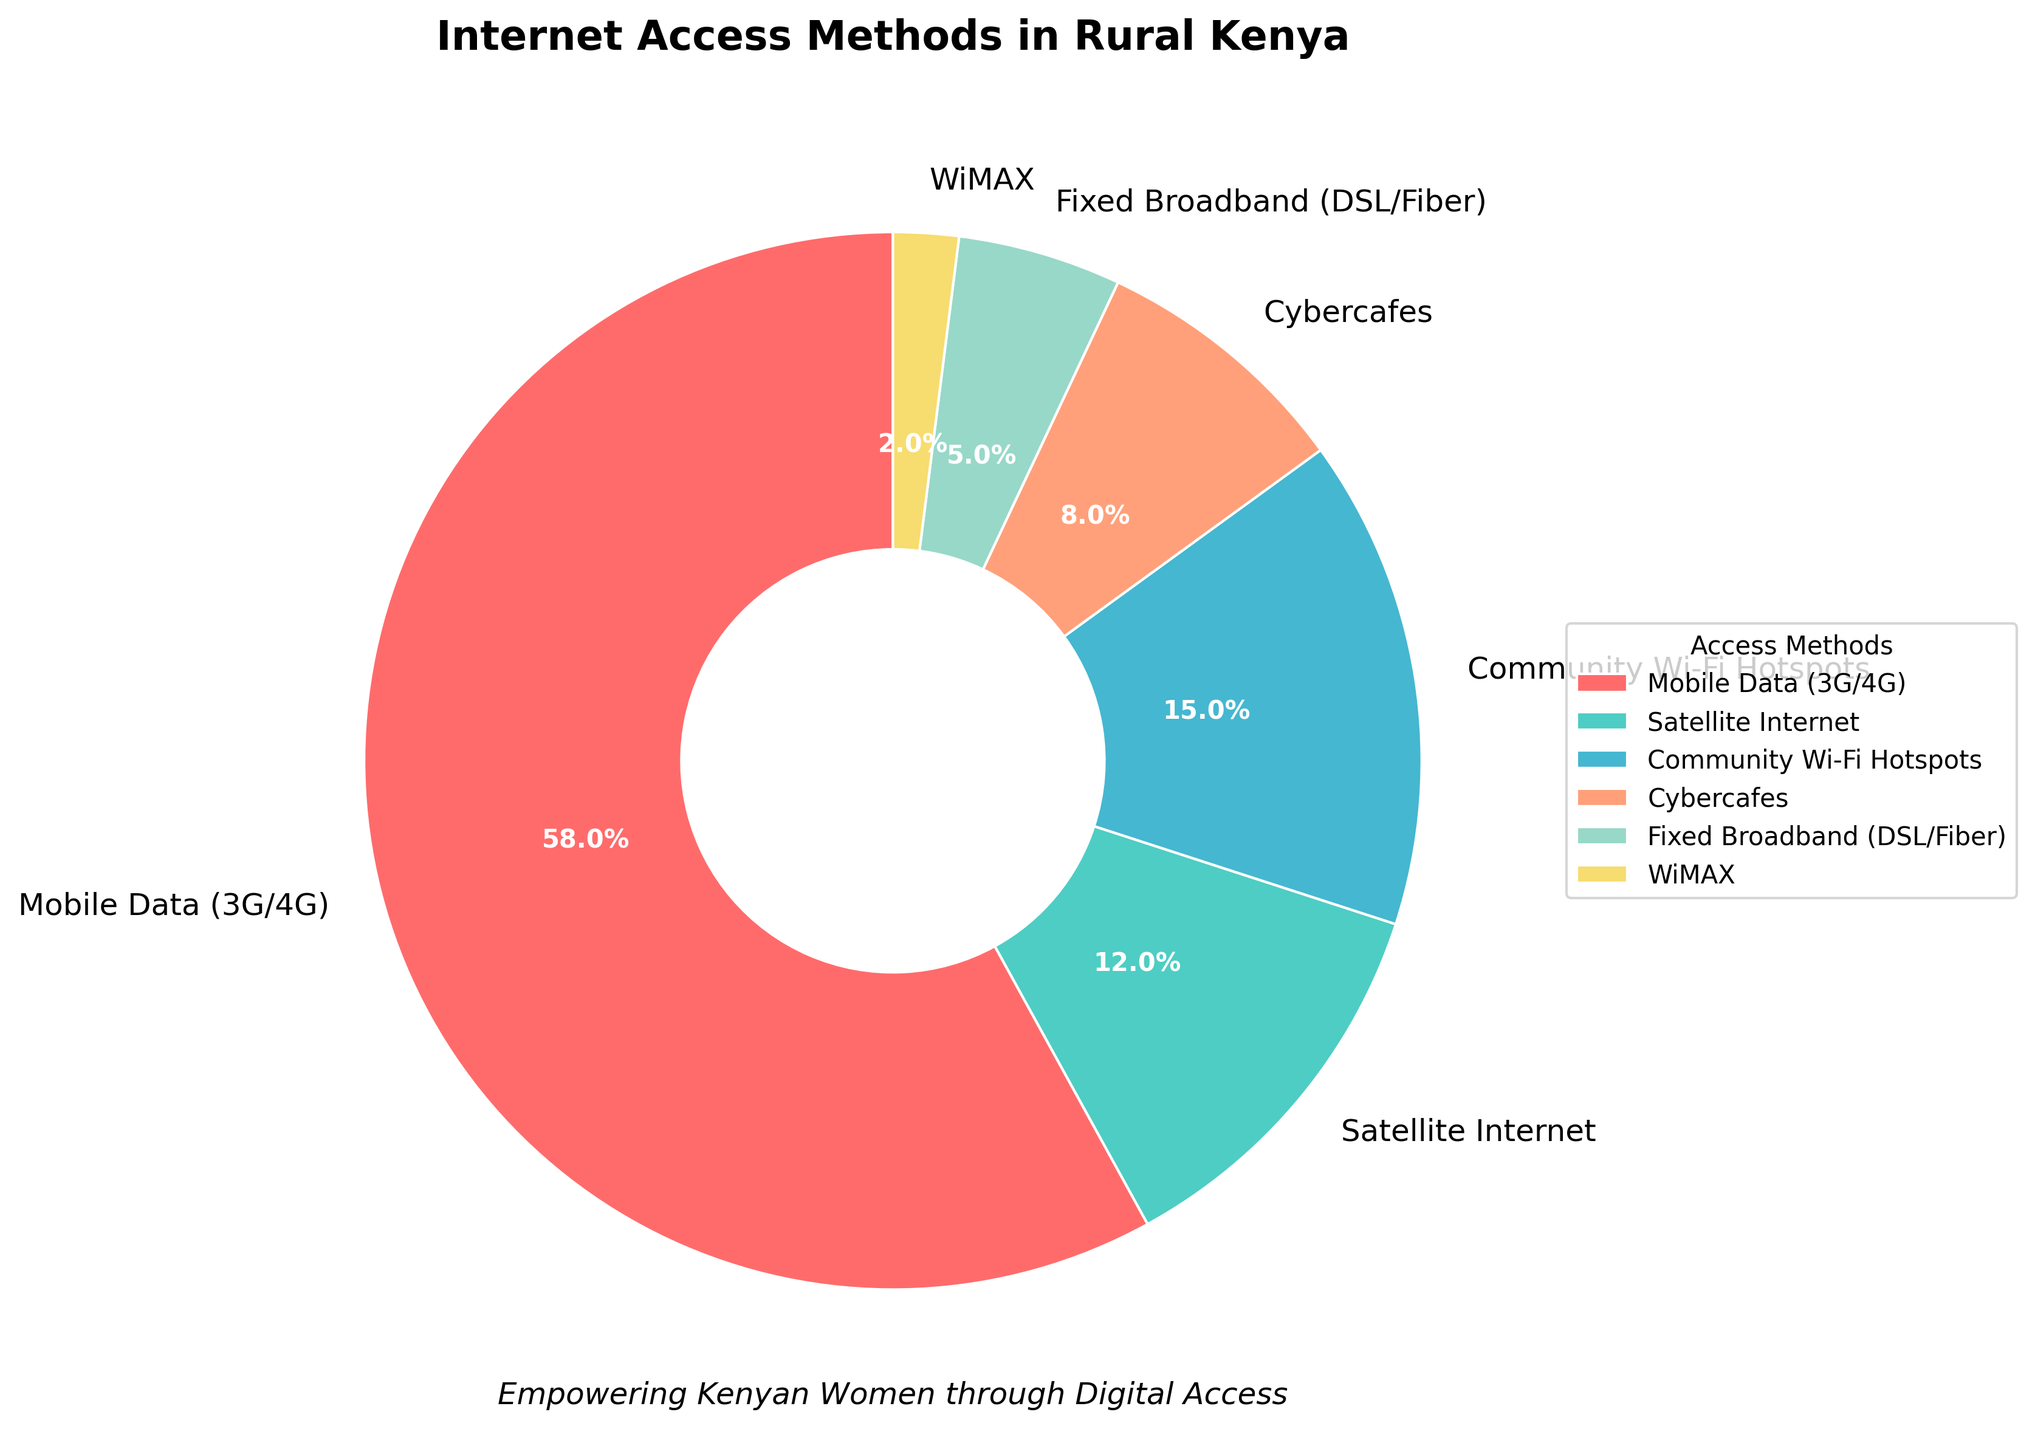What percentage of rural Kenya’s internet access comes from mobile data? Mobile data represents 58% of the total internet access methods. This can be directly observed from the chart's labeling.
Answer: 58% Which internet access method is more common in rural Kenya, satellite internet or community Wi-Fi hotspots? Community Wi-Fi hotspots account for 15% of the internet access compared to satellite internet's 12%. Therefore, community Wi-Fi hotspots are more common.
Answer: Community Wi-Fi hotspots What’s the combined percentage of internet access methods other than mobile data and community Wi-Fi hotspots? Summing up the percentages of Satellite Internet (12%), Cybercafes (8%), Fixed Broadband (5%), and WiMAX (2%) gives us 12 + 8 + 5 + 2 = 27%.
Answer: 27% Which internet access method accounts for the smallest percentage in rural Kenya? WiMAX accounts for the smallest percentage at 2%, as indicated by its corresponding section in the pie chart.
Answer: WiMAX Compare the total percentage of community Wi-Fi hotspots and cybercafes to mobile data access. Is it greater or smaller? The combined percentage of community Wi-Fi hotspots (15%) and cybercafes (8%) is 15 + 8 = 23%. This is smaller than the mobile data access percentage (58%).
Answer: Smaller What visual element indicates the dominant method of internet access in rural Kenya? The largest slice of the pie chart, which is colored red, indicates that mobile data (3G/4G) is the dominant method, representing 58%.
Answer: Red slice Among satellite internet, cybercafes, and fixed broadband, which provides greater internet access in rural Kenya? Satellite internet provides 12% while cybercafes supply 8%, and fixed broadband gives 5%. Thus, satellite internet provides the greatest access among these three methods.
Answer: Satellite internet What is the difference in percentage between the most and the least common internet access methods? The most common method is mobile data at 58%, and the least common is WiMAX at 2%. The difference is 58 - 2 = 56%.
Answer: 56% How does the percentage of fixed broadband compare to that of community Wi-Fi hotspots? Fixed broadband accounts for 5% of the internet access while community Wi-Fi hotspots account for 15%. Hence, community Wi-Fi hotspots are three times more common than fixed broadband.
Answer: Community Wi-Fi hotspots are three times more common Which internet access methods collectively account for less than 10% each? Cybercafes (8%), Fixed Broadband (5%), and WiMAX (2%) are each less than 10% of the total internet access methods. Summing them confirms they each fall below the 10% mark.
Answer: Cybercafes, Fixed Broadband, WiMAX 